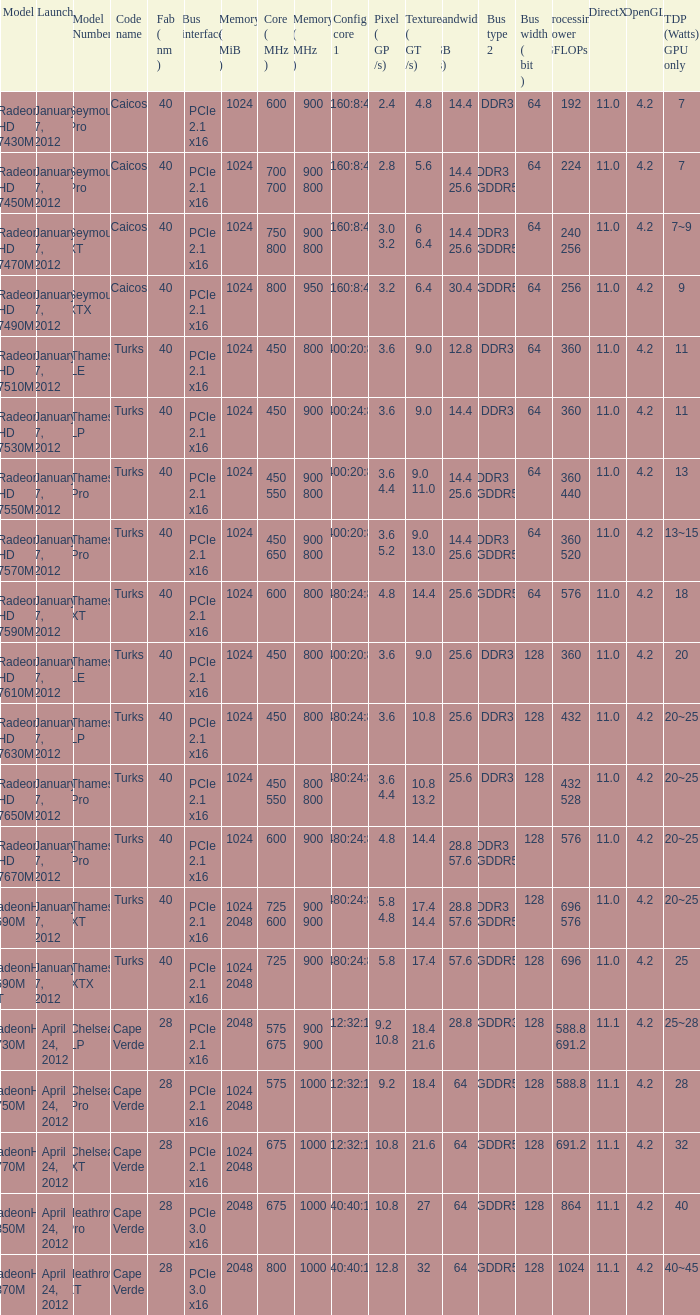What is the config core 1 of the model with a processing power GFLOPs of 432? 480:24:8. 